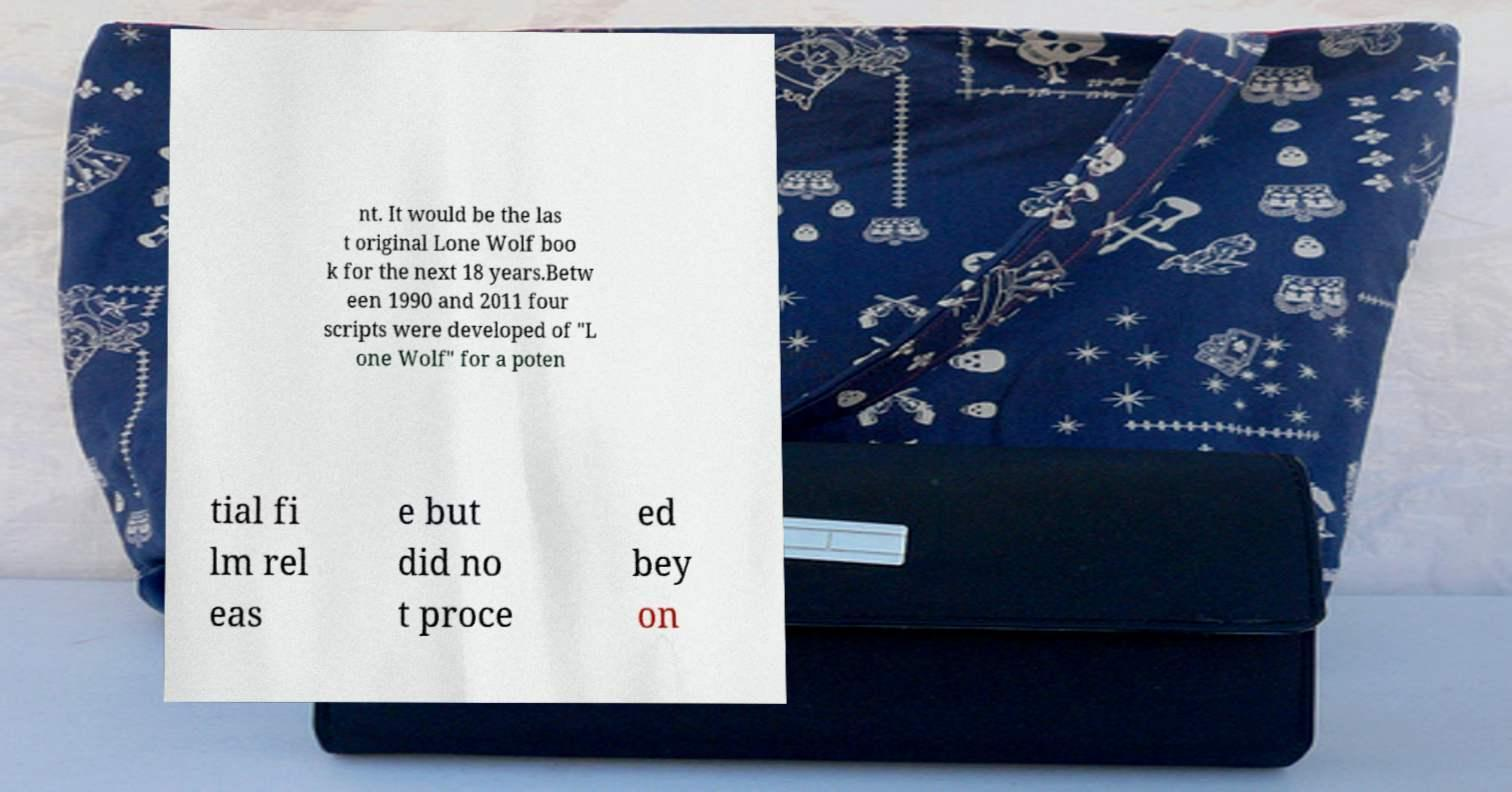Could you extract and type out the text from this image? nt. It would be the las t original Lone Wolf boo k for the next 18 years.Betw een 1990 and 2011 four scripts were developed of "L one Wolf" for a poten tial fi lm rel eas e but did no t proce ed bey on 